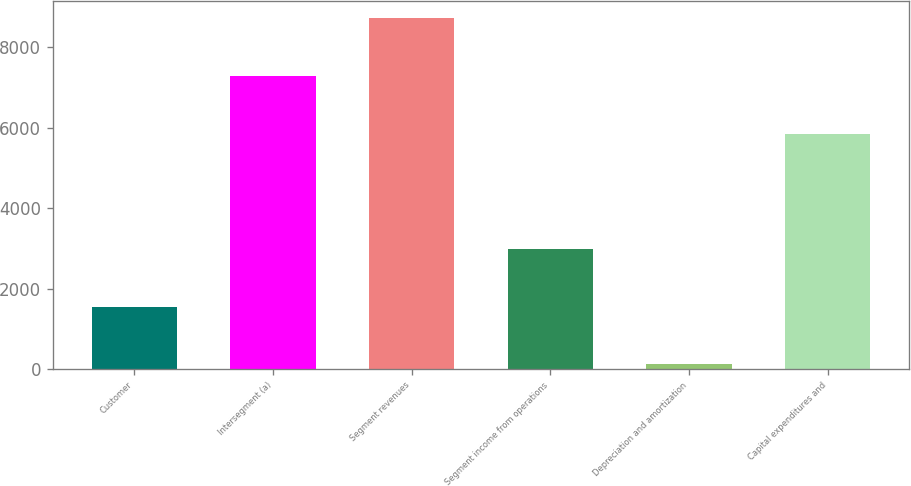Convert chart. <chart><loc_0><loc_0><loc_500><loc_500><bar_chart><fcel>Customer<fcel>Intersegment (a)<fcel>Segment revenues<fcel>Segment income from operations<fcel>Depreciation and amortization<fcel>Capital expenditures and<nl><fcel>1550<fcel>7282<fcel>8715<fcel>2983<fcel>117<fcel>5849<nl></chart> 